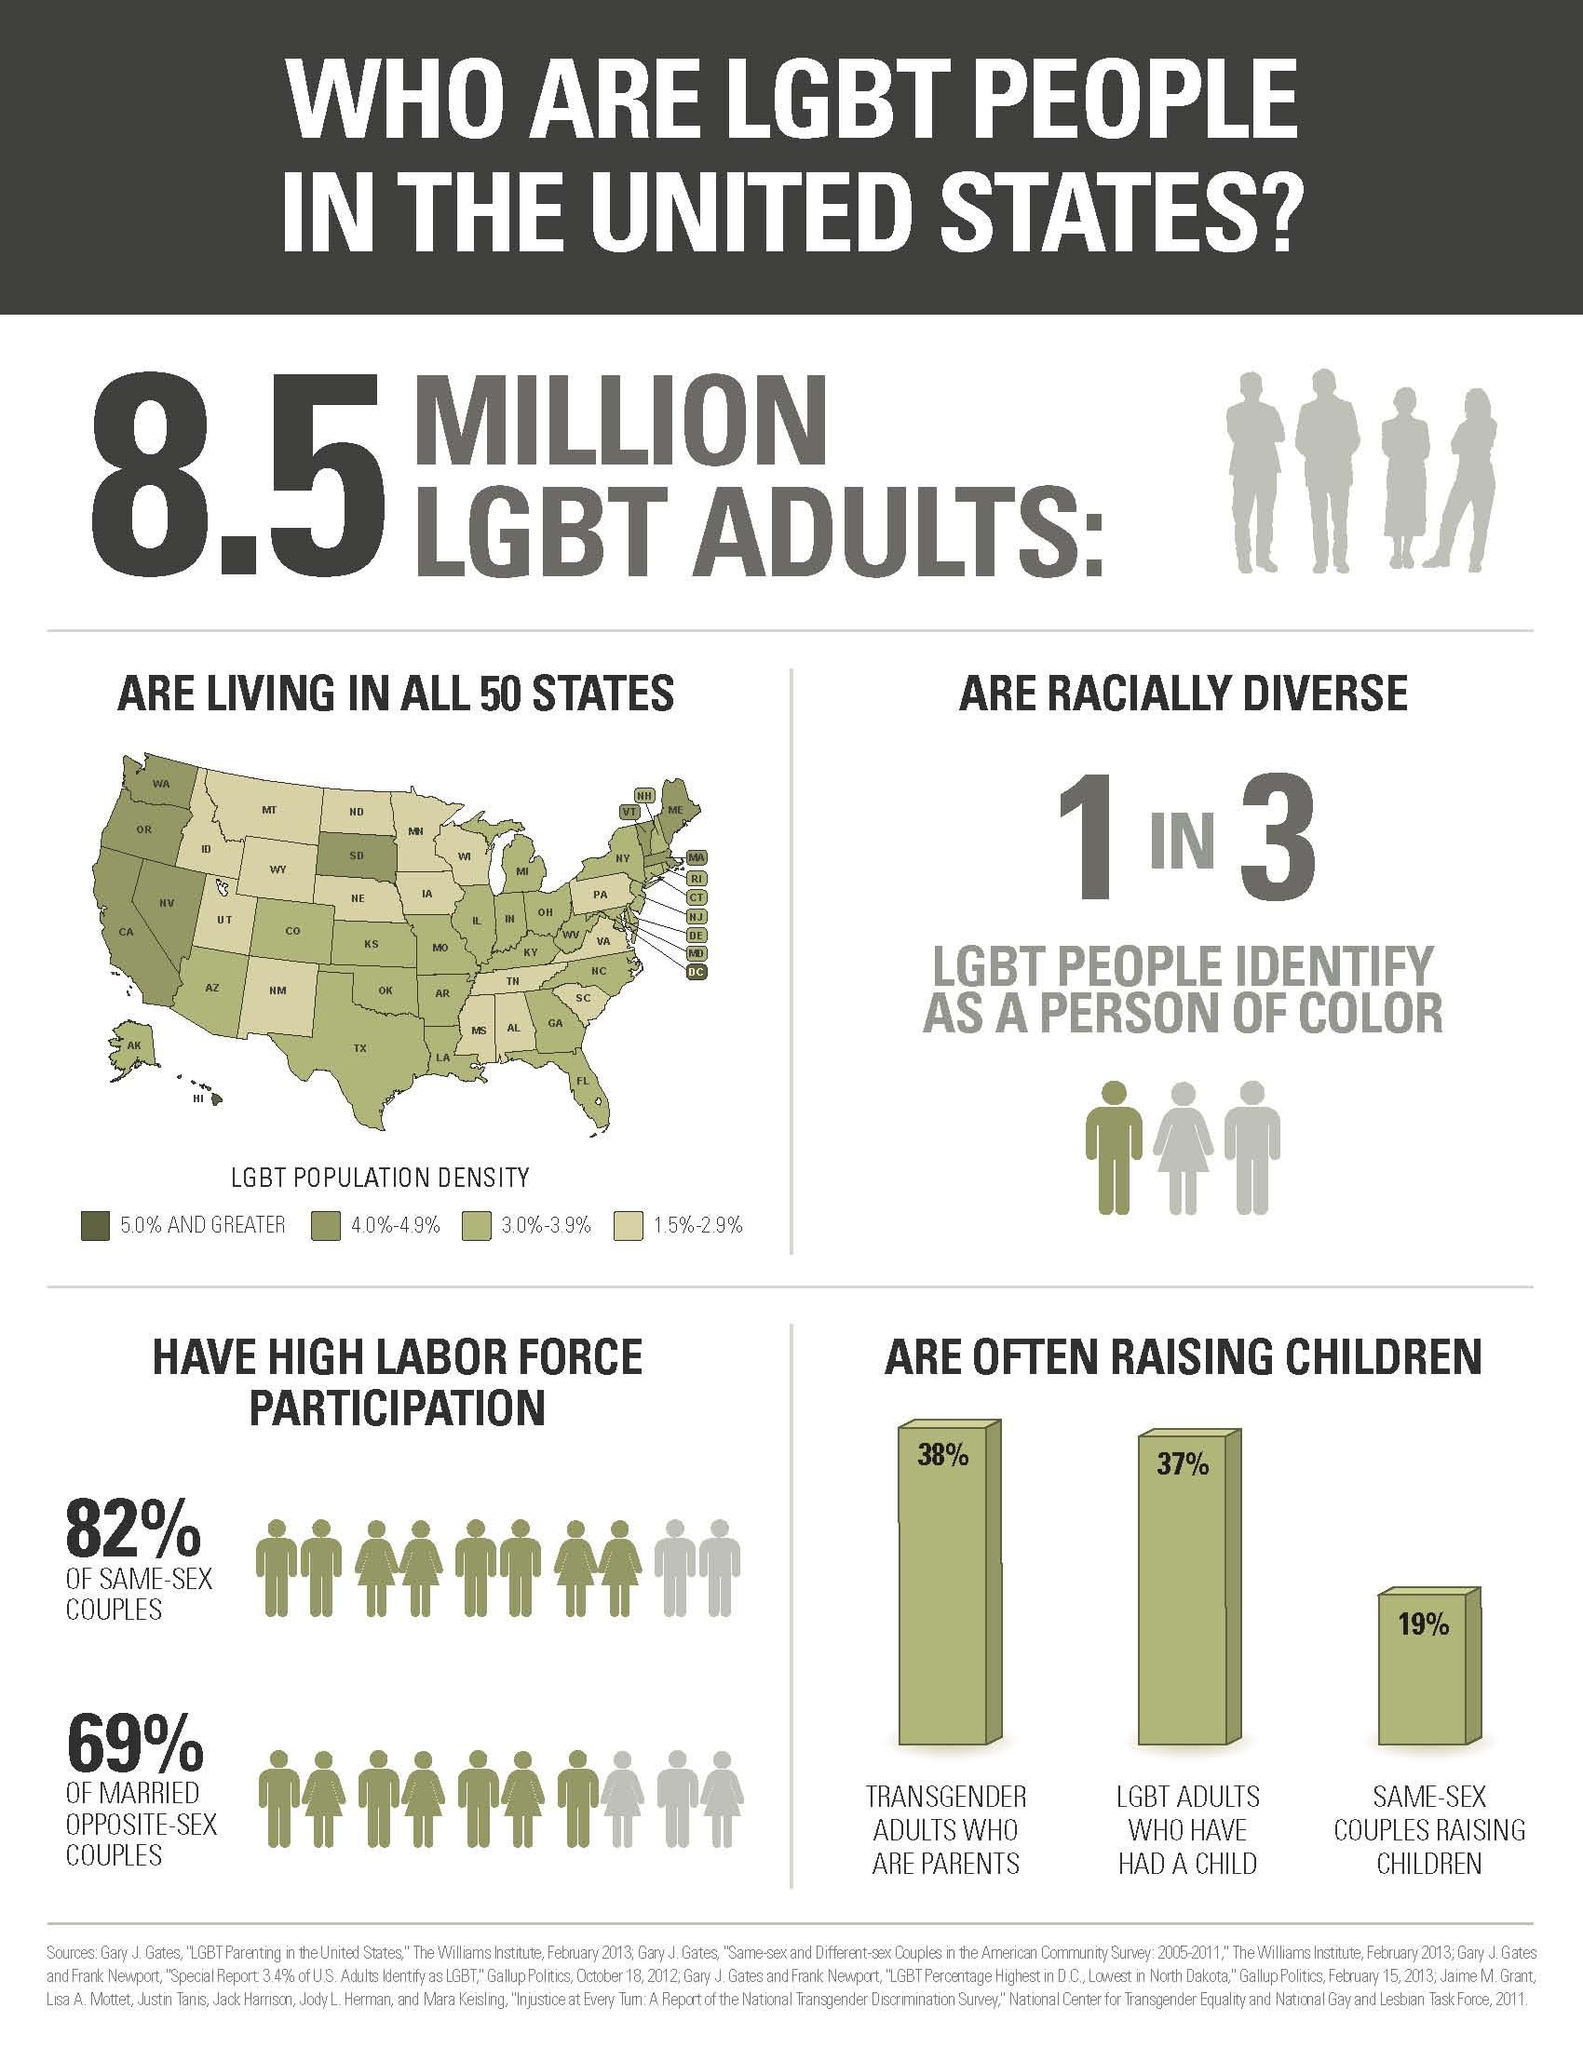Mention a couple of crucial points in this snapshot. According to recent statistics, approximately 19% of same-sex couples in the United States are raising children. According to a recent survey, 37% of LGBT adults in the United States have had a child. The LGBT population density in the state of Washington (WA) in the United States is approximately 4.0% to 4.9%. The LGBT population in New Mexico, a state in the United States, is estimated to be between 1.5% and 2.9% of the total population. The total LGBT population in the United States is approximately 8.5 million. 